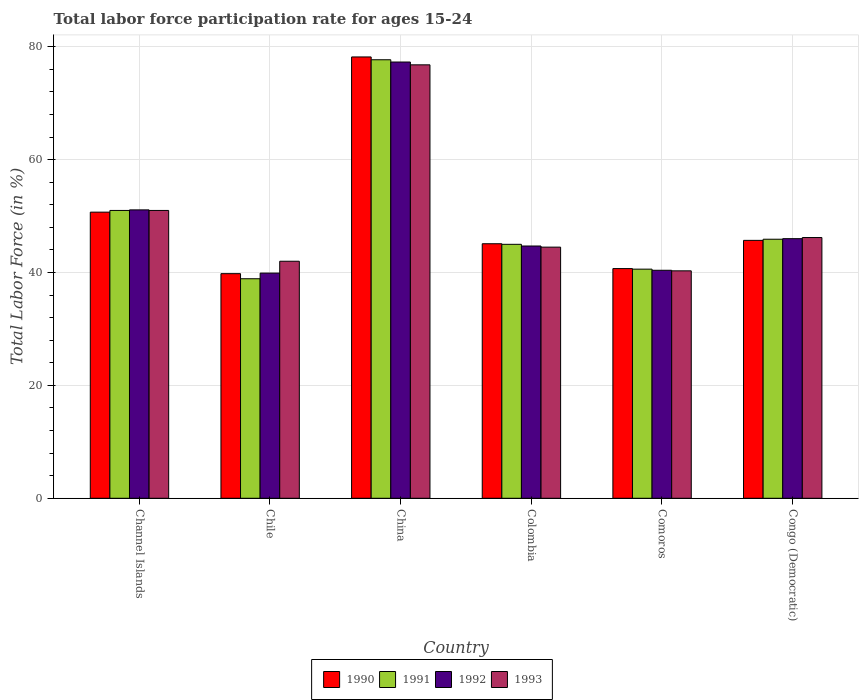How many different coloured bars are there?
Your answer should be very brief. 4. How many bars are there on the 1st tick from the right?
Give a very brief answer. 4. What is the label of the 3rd group of bars from the left?
Offer a terse response. China. In how many cases, is the number of bars for a given country not equal to the number of legend labels?
Give a very brief answer. 0. What is the labor force participation rate in 1991 in Chile?
Your answer should be compact. 38.9. Across all countries, what is the maximum labor force participation rate in 1992?
Give a very brief answer. 77.3. Across all countries, what is the minimum labor force participation rate in 1992?
Offer a terse response. 39.9. In which country was the labor force participation rate in 1991 minimum?
Keep it short and to the point. Chile. What is the total labor force participation rate in 1993 in the graph?
Your answer should be compact. 300.8. What is the difference between the labor force participation rate in 1990 in China and that in Congo (Democratic)?
Your response must be concise. 32.5. What is the difference between the labor force participation rate in 1990 in Channel Islands and the labor force participation rate in 1993 in Comoros?
Keep it short and to the point. 10.4. What is the average labor force participation rate in 1991 per country?
Keep it short and to the point. 49.85. What is the difference between the labor force participation rate of/in 1993 and labor force participation rate of/in 1991 in Congo (Democratic)?
Offer a very short reply. 0.3. In how many countries, is the labor force participation rate in 1991 greater than 36 %?
Your answer should be compact. 6. What is the ratio of the labor force participation rate in 1992 in Channel Islands to that in Chile?
Your answer should be compact. 1.28. Is the labor force participation rate in 1991 in Colombia less than that in Congo (Democratic)?
Your answer should be compact. Yes. Is the difference between the labor force participation rate in 1993 in Colombia and Comoros greater than the difference between the labor force participation rate in 1991 in Colombia and Comoros?
Give a very brief answer. No. What is the difference between the highest and the second highest labor force participation rate in 1992?
Offer a very short reply. -26.2. What is the difference between the highest and the lowest labor force participation rate in 1992?
Offer a terse response. 37.4. In how many countries, is the labor force participation rate in 1992 greater than the average labor force participation rate in 1992 taken over all countries?
Offer a terse response. 2. Is it the case that in every country, the sum of the labor force participation rate in 1992 and labor force participation rate in 1990 is greater than the sum of labor force participation rate in 1991 and labor force participation rate in 1993?
Offer a very short reply. No. What does the 3rd bar from the right in China represents?
Your response must be concise. 1991. Is it the case that in every country, the sum of the labor force participation rate in 1992 and labor force participation rate in 1993 is greater than the labor force participation rate in 1990?
Ensure brevity in your answer.  Yes. Are all the bars in the graph horizontal?
Provide a short and direct response. No. Does the graph contain grids?
Provide a short and direct response. Yes. How are the legend labels stacked?
Offer a terse response. Horizontal. What is the title of the graph?
Your response must be concise. Total labor force participation rate for ages 15-24. What is the label or title of the X-axis?
Make the answer very short. Country. What is the Total Labor Force (in %) in 1990 in Channel Islands?
Provide a short and direct response. 50.7. What is the Total Labor Force (in %) in 1991 in Channel Islands?
Your answer should be compact. 51. What is the Total Labor Force (in %) of 1992 in Channel Islands?
Give a very brief answer. 51.1. What is the Total Labor Force (in %) of 1993 in Channel Islands?
Your answer should be compact. 51. What is the Total Labor Force (in %) in 1990 in Chile?
Provide a succinct answer. 39.8. What is the Total Labor Force (in %) in 1991 in Chile?
Make the answer very short. 38.9. What is the Total Labor Force (in %) in 1992 in Chile?
Your answer should be compact. 39.9. What is the Total Labor Force (in %) in 1993 in Chile?
Offer a very short reply. 42. What is the Total Labor Force (in %) in 1990 in China?
Provide a short and direct response. 78.2. What is the Total Labor Force (in %) of 1991 in China?
Ensure brevity in your answer.  77.7. What is the Total Labor Force (in %) in 1992 in China?
Your answer should be very brief. 77.3. What is the Total Labor Force (in %) of 1993 in China?
Your response must be concise. 76.8. What is the Total Labor Force (in %) of 1990 in Colombia?
Your answer should be very brief. 45.1. What is the Total Labor Force (in %) of 1991 in Colombia?
Your answer should be compact. 45. What is the Total Labor Force (in %) in 1992 in Colombia?
Offer a terse response. 44.7. What is the Total Labor Force (in %) in 1993 in Colombia?
Offer a very short reply. 44.5. What is the Total Labor Force (in %) of 1990 in Comoros?
Your answer should be very brief. 40.7. What is the Total Labor Force (in %) of 1991 in Comoros?
Your answer should be compact. 40.6. What is the Total Labor Force (in %) in 1992 in Comoros?
Keep it short and to the point. 40.4. What is the Total Labor Force (in %) of 1993 in Comoros?
Your response must be concise. 40.3. What is the Total Labor Force (in %) in 1990 in Congo (Democratic)?
Offer a very short reply. 45.7. What is the Total Labor Force (in %) of 1991 in Congo (Democratic)?
Keep it short and to the point. 45.9. What is the Total Labor Force (in %) of 1993 in Congo (Democratic)?
Your answer should be very brief. 46.2. Across all countries, what is the maximum Total Labor Force (in %) of 1990?
Give a very brief answer. 78.2. Across all countries, what is the maximum Total Labor Force (in %) in 1991?
Ensure brevity in your answer.  77.7. Across all countries, what is the maximum Total Labor Force (in %) of 1992?
Ensure brevity in your answer.  77.3. Across all countries, what is the maximum Total Labor Force (in %) of 1993?
Keep it short and to the point. 76.8. Across all countries, what is the minimum Total Labor Force (in %) of 1990?
Offer a terse response. 39.8. Across all countries, what is the minimum Total Labor Force (in %) in 1991?
Give a very brief answer. 38.9. Across all countries, what is the minimum Total Labor Force (in %) of 1992?
Offer a terse response. 39.9. Across all countries, what is the minimum Total Labor Force (in %) of 1993?
Your response must be concise. 40.3. What is the total Total Labor Force (in %) of 1990 in the graph?
Make the answer very short. 300.2. What is the total Total Labor Force (in %) in 1991 in the graph?
Ensure brevity in your answer.  299.1. What is the total Total Labor Force (in %) in 1992 in the graph?
Make the answer very short. 299.4. What is the total Total Labor Force (in %) in 1993 in the graph?
Your answer should be compact. 300.8. What is the difference between the Total Labor Force (in %) in 1991 in Channel Islands and that in Chile?
Your answer should be very brief. 12.1. What is the difference between the Total Labor Force (in %) of 1990 in Channel Islands and that in China?
Offer a terse response. -27.5. What is the difference between the Total Labor Force (in %) in 1991 in Channel Islands and that in China?
Provide a short and direct response. -26.7. What is the difference between the Total Labor Force (in %) of 1992 in Channel Islands and that in China?
Ensure brevity in your answer.  -26.2. What is the difference between the Total Labor Force (in %) of 1993 in Channel Islands and that in China?
Ensure brevity in your answer.  -25.8. What is the difference between the Total Labor Force (in %) in 1990 in Channel Islands and that in Colombia?
Your answer should be compact. 5.6. What is the difference between the Total Labor Force (in %) of 1991 in Channel Islands and that in Colombia?
Give a very brief answer. 6. What is the difference between the Total Labor Force (in %) of 1992 in Channel Islands and that in Colombia?
Your answer should be compact. 6.4. What is the difference between the Total Labor Force (in %) in 1990 in Channel Islands and that in Comoros?
Ensure brevity in your answer.  10. What is the difference between the Total Labor Force (in %) of 1991 in Channel Islands and that in Comoros?
Your response must be concise. 10.4. What is the difference between the Total Labor Force (in %) in 1993 in Channel Islands and that in Comoros?
Your response must be concise. 10.7. What is the difference between the Total Labor Force (in %) in 1990 in Channel Islands and that in Congo (Democratic)?
Offer a very short reply. 5. What is the difference between the Total Labor Force (in %) of 1993 in Channel Islands and that in Congo (Democratic)?
Offer a terse response. 4.8. What is the difference between the Total Labor Force (in %) of 1990 in Chile and that in China?
Make the answer very short. -38.4. What is the difference between the Total Labor Force (in %) of 1991 in Chile and that in China?
Provide a succinct answer. -38.8. What is the difference between the Total Labor Force (in %) in 1992 in Chile and that in China?
Offer a very short reply. -37.4. What is the difference between the Total Labor Force (in %) of 1993 in Chile and that in China?
Provide a succinct answer. -34.8. What is the difference between the Total Labor Force (in %) in 1990 in Chile and that in Colombia?
Your response must be concise. -5.3. What is the difference between the Total Labor Force (in %) of 1993 in Chile and that in Colombia?
Provide a short and direct response. -2.5. What is the difference between the Total Labor Force (in %) in 1992 in Chile and that in Comoros?
Keep it short and to the point. -0.5. What is the difference between the Total Labor Force (in %) of 1993 in Chile and that in Comoros?
Give a very brief answer. 1.7. What is the difference between the Total Labor Force (in %) of 1990 in Chile and that in Congo (Democratic)?
Keep it short and to the point. -5.9. What is the difference between the Total Labor Force (in %) of 1990 in China and that in Colombia?
Your answer should be compact. 33.1. What is the difference between the Total Labor Force (in %) of 1991 in China and that in Colombia?
Give a very brief answer. 32.7. What is the difference between the Total Labor Force (in %) of 1992 in China and that in Colombia?
Keep it short and to the point. 32.6. What is the difference between the Total Labor Force (in %) of 1993 in China and that in Colombia?
Offer a terse response. 32.3. What is the difference between the Total Labor Force (in %) of 1990 in China and that in Comoros?
Give a very brief answer. 37.5. What is the difference between the Total Labor Force (in %) of 1991 in China and that in Comoros?
Make the answer very short. 37.1. What is the difference between the Total Labor Force (in %) of 1992 in China and that in Comoros?
Offer a terse response. 36.9. What is the difference between the Total Labor Force (in %) in 1993 in China and that in Comoros?
Ensure brevity in your answer.  36.5. What is the difference between the Total Labor Force (in %) of 1990 in China and that in Congo (Democratic)?
Your answer should be very brief. 32.5. What is the difference between the Total Labor Force (in %) of 1991 in China and that in Congo (Democratic)?
Give a very brief answer. 31.8. What is the difference between the Total Labor Force (in %) of 1992 in China and that in Congo (Democratic)?
Your response must be concise. 31.3. What is the difference between the Total Labor Force (in %) of 1993 in China and that in Congo (Democratic)?
Ensure brevity in your answer.  30.6. What is the difference between the Total Labor Force (in %) in 1990 in Colombia and that in Comoros?
Your response must be concise. 4.4. What is the difference between the Total Labor Force (in %) of 1991 in Colombia and that in Comoros?
Provide a succinct answer. 4.4. What is the difference between the Total Labor Force (in %) in 1993 in Colombia and that in Comoros?
Your answer should be compact. 4.2. What is the difference between the Total Labor Force (in %) in 1990 in Colombia and that in Congo (Democratic)?
Offer a very short reply. -0.6. What is the difference between the Total Labor Force (in %) in 1993 in Comoros and that in Congo (Democratic)?
Keep it short and to the point. -5.9. What is the difference between the Total Labor Force (in %) of 1990 in Channel Islands and the Total Labor Force (in %) of 1991 in Chile?
Your response must be concise. 11.8. What is the difference between the Total Labor Force (in %) in 1990 in Channel Islands and the Total Labor Force (in %) in 1992 in Chile?
Your response must be concise. 10.8. What is the difference between the Total Labor Force (in %) of 1991 in Channel Islands and the Total Labor Force (in %) of 1992 in Chile?
Give a very brief answer. 11.1. What is the difference between the Total Labor Force (in %) in 1991 in Channel Islands and the Total Labor Force (in %) in 1993 in Chile?
Your response must be concise. 9. What is the difference between the Total Labor Force (in %) in 1990 in Channel Islands and the Total Labor Force (in %) in 1991 in China?
Your answer should be very brief. -27. What is the difference between the Total Labor Force (in %) in 1990 in Channel Islands and the Total Labor Force (in %) in 1992 in China?
Make the answer very short. -26.6. What is the difference between the Total Labor Force (in %) in 1990 in Channel Islands and the Total Labor Force (in %) in 1993 in China?
Provide a succinct answer. -26.1. What is the difference between the Total Labor Force (in %) of 1991 in Channel Islands and the Total Labor Force (in %) of 1992 in China?
Give a very brief answer. -26.3. What is the difference between the Total Labor Force (in %) of 1991 in Channel Islands and the Total Labor Force (in %) of 1993 in China?
Offer a terse response. -25.8. What is the difference between the Total Labor Force (in %) of 1992 in Channel Islands and the Total Labor Force (in %) of 1993 in China?
Offer a very short reply. -25.7. What is the difference between the Total Labor Force (in %) of 1990 in Channel Islands and the Total Labor Force (in %) of 1991 in Colombia?
Provide a short and direct response. 5.7. What is the difference between the Total Labor Force (in %) of 1990 in Channel Islands and the Total Labor Force (in %) of 1992 in Colombia?
Your response must be concise. 6. What is the difference between the Total Labor Force (in %) of 1991 in Channel Islands and the Total Labor Force (in %) of 1992 in Colombia?
Make the answer very short. 6.3. What is the difference between the Total Labor Force (in %) of 1991 in Channel Islands and the Total Labor Force (in %) of 1993 in Colombia?
Offer a very short reply. 6.5. What is the difference between the Total Labor Force (in %) in 1992 in Channel Islands and the Total Labor Force (in %) in 1993 in Colombia?
Keep it short and to the point. 6.6. What is the difference between the Total Labor Force (in %) in 1990 in Channel Islands and the Total Labor Force (in %) in 1991 in Comoros?
Provide a succinct answer. 10.1. What is the difference between the Total Labor Force (in %) in 1991 in Channel Islands and the Total Labor Force (in %) in 1993 in Comoros?
Give a very brief answer. 10.7. What is the difference between the Total Labor Force (in %) of 1992 in Channel Islands and the Total Labor Force (in %) of 1993 in Comoros?
Keep it short and to the point. 10.8. What is the difference between the Total Labor Force (in %) of 1990 in Channel Islands and the Total Labor Force (in %) of 1991 in Congo (Democratic)?
Offer a terse response. 4.8. What is the difference between the Total Labor Force (in %) in 1990 in Channel Islands and the Total Labor Force (in %) in 1992 in Congo (Democratic)?
Keep it short and to the point. 4.7. What is the difference between the Total Labor Force (in %) of 1990 in Chile and the Total Labor Force (in %) of 1991 in China?
Your response must be concise. -37.9. What is the difference between the Total Labor Force (in %) in 1990 in Chile and the Total Labor Force (in %) in 1992 in China?
Keep it short and to the point. -37.5. What is the difference between the Total Labor Force (in %) of 1990 in Chile and the Total Labor Force (in %) of 1993 in China?
Keep it short and to the point. -37. What is the difference between the Total Labor Force (in %) of 1991 in Chile and the Total Labor Force (in %) of 1992 in China?
Your answer should be very brief. -38.4. What is the difference between the Total Labor Force (in %) in 1991 in Chile and the Total Labor Force (in %) in 1993 in China?
Give a very brief answer. -37.9. What is the difference between the Total Labor Force (in %) in 1992 in Chile and the Total Labor Force (in %) in 1993 in China?
Keep it short and to the point. -36.9. What is the difference between the Total Labor Force (in %) in 1990 in Chile and the Total Labor Force (in %) in 1992 in Colombia?
Offer a very short reply. -4.9. What is the difference between the Total Labor Force (in %) of 1990 in Chile and the Total Labor Force (in %) of 1993 in Colombia?
Ensure brevity in your answer.  -4.7. What is the difference between the Total Labor Force (in %) in 1991 in Chile and the Total Labor Force (in %) in 1992 in Colombia?
Your response must be concise. -5.8. What is the difference between the Total Labor Force (in %) in 1991 in Chile and the Total Labor Force (in %) in 1993 in Colombia?
Keep it short and to the point. -5.6. What is the difference between the Total Labor Force (in %) of 1990 in Chile and the Total Labor Force (in %) of 1992 in Comoros?
Your response must be concise. -0.6. What is the difference between the Total Labor Force (in %) of 1990 in Chile and the Total Labor Force (in %) of 1993 in Comoros?
Provide a succinct answer. -0.5. What is the difference between the Total Labor Force (in %) of 1991 in Chile and the Total Labor Force (in %) of 1993 in Comoros?
Offer a terse response. -1.4. What is the difference between the Total Labor Force (in %) of 1990 in Chile and the Total Labor Force (in %) of 1991 in Congo (Democratic)?
Keep it short and to the point. -6.1. What is the difference between the Total Labor Force (in %) of 1990 in Chile and the Total Labor Force (in %) of 1992 in Congo (Democratic)?
Provide a succinct answer. -6.2. What is the difference between the Total Labor Force (in %) of 1990 in Chile and the Total Labor Force (in %) of 1993 in Congo (Democratic)?
Provide a succinct answer. -6.4. What is the difference between the Total Labor Force (in %) in 1991 in Chile and the Total Labor Force (in %) in 1992 in Congo (Democratic)?
Your response must be concise. -7.1. What is the difference between the Total Labor Force (in %) of 1991 in Chile and the Total Labor Force (in %) of 1993 in Congo (Democratic)?
Your answer should be very brief. -7.3. What is the difference between the Total Labor Force (in %) of 1990 in China and the Total Labor Force (in %) of 1991 in Colombia?
Your response must be concise. 33.2. What is the difference between the Total Labor Force (in %) of 1990 in China and the Total Labor Force (in %) of 1992 in Colombia?
Provide a succinct answer. 33.5. What is the difference between the Total Labor Force (in %) of 1990 in China and the Total Labor Force (in %) of 1993 in Colombia?
Offer a terse response. 33.7. What is the difference between the Total Labor Force (in %) in 1991 in China and the Total Labor Force (in %) in 1993 in Colombia?
Provide a succinct answer. 33.2. What is the difference between the Total Labor Force (in %) in 1992 in China and the Total Labor Force (in %) in 1993 in Colombia?
Ensure brevity in your answer.  32.8. What is the difference between the Total Labor Force (in %) of 1990 in China and the Total Labor Force (in %) of 1991 in Comoros?
Offer a very short reply. 37.6. What is the difference between the Total Labor Force (in %) of 1990 in China and the Total Labor Force (in %) of 1992 in Comoros?
Provide a succinct answer. 37.8. What is the difference between the Total Labor Force (in %) of 1990 in China and the Total Labor Force (in %) of 1993 in Comoros?
Make the answer very short. 37.9. What is the difference between the Total Labor Force (in %) of 1991 in China and the Total Labor Force (in %) of 1992 in Comoros?
Ensure brevity in your answer.  37.3. What is the difference between the Total Labor Force (in %) in 1991 in China and the Total Labor Force (in %) in 1993 in Comoros?
Keep it short and to the point. 37.4. What is the difference between the Total Labor Force (in %) in 1990 in China and the Total Labor Force (in %) in 1991 in Congo (Democratic)?
Your answer should be very brief. 32.3. What is the difference between the Total Labor Force (in %) in 1990 in China and the Total Labor Force (in %) in 1992 in Congo (Democratic)?
Keep it short and to the point. 32.2. What is the difference between the Total Labor Force (in %) in 1990 in China and the Total Labor Force (in %) in 1993 in Congo (Democratic)?
Keep it short and to the point. 32. What is the difference between the Total Labor Force (in %) of 1991 in China and the Total Labor Force (in %) of 1992 in Congo (Democratic)?
Ensure brevity in your answer.  31.7. What is the difference between the Total Labor Force (in %) of 1991 in China and the Total Labor Force (in %) of 1993 in Congo (Democratic)?
Your answer should be compact. 31.5. What is the difference between the Total Labor Force (in %) in 1992 in China and the Total Labor Force (in %) in 1993 in Congo (Democratic)?
Give a very brief answer. 31.1. What is the difference between the Total Labor Force (in %) in 1990 in Colombia and the Total Labor Force (in %) in 1991 in Comoros?
Your answer should be compact. 4.5. What is the difference between the Total Labor Force (in %) in 1991 in Colombia and the Total Labor Force (in %) in 1992 in Comoros?
Give a very brief answer. 4.6. What is the difference between the Total Labor Force (in %) of 1992 in Colombia and the Total Labor Force (in %) of 1993 in Comoros?
Provide a succinct answer. 4.4. What is the difference between the Total Labor Force (in %) of 1990 in Colombia and the Total Labor Force (in %) of 1991 in Congo (Democratic)?
Provide a short and direct response. -0.8. What is the difference between the Total Labor Force (in %) of 1991 in Colombia and the Total Labor Force (in %) of 1992 in Congo (Democratic)?
Keep it short and to the point. -1. What is the difference between the Total Labor Force (in %) in 1990 in Comoros and the Total Labor Force (in %) in 1991 in Congo (Democratic)?
Offer a very short reply. -5.2. What is the difference between the Total Labor Force (in %) in 1990 in Comoros and the Total Labor Force (in %) in 1993 in Congo (Democratic)?
Provide a short and direct response. -5.5. What is the difference between the Total Labor Force (in %) in 1991 in Comoros and the Total Labor Force (in %) in 1993 in Congo (Democratic)?
Your answer should be compact. -5.6. What is the difference between the Total Labor Force (in %) in 1992 in Comoros and the Total Labor Force (in %) in 1993 in Congo (Democratic)?
Your answer should be very brief. -5.8. What is the average Total Labor Force (in %) of 1990 per country?
Give a very brief answer. 50.03. What is the average Total Labor Force (in %) of 1991 per country?
Offer a terse response. 49.85. What is the average Total Labor Force (in %) in 1992 per country?
Offer a very short reply. 49.9. What is the average Total Labor Force (in %) of 1993 per country?
Make the answer very short. 50.13. What is the difference between the Total Labor Force (in %) of 1990 and Total Labor Force (in %) of 1991 in Channel Islands?
Offer a very short reply. -0.3. What is the difference between the Total Labor Force (in %) in 1990 and Total Labor Force (in %) in 1993 in Channel Islands?
Your answer should be very brief. -0.3. What is the difference between the Total Labor Force (in %) of 1991 and Total Labor Force (in %) of 1992 in Channel Islands?
Your response must be concise. -0.1. What is the difference between the Total Labor Force (in %) in 1992 and Total Labor Force (in %) in 1993 in Channel Islands?
Keep it short and to the point. 0.1. What is the difference between the Total Labor Force (in %) of 1991 and Total Labor Force (in %) of 1992 in Chile?
Your answer should be very brief. -1. What is the difference between the Total Labor Force (in %) in 1990 and Total Labor Force (in %) in 1992 in China?
Give a very brief answer. 0.9. What is the difference between the Total Labor Force (in %) in 1990 and Total Labor Force (in %) in 1993 in China?
Make the answer very short. 1.4. What is the difference between the Total Labor Force (in %) in 1991 and Total Labor Force (in %) in 1992 in China?
Offer a terse response. 0.4. What is the difference between the Total Labor Force (in %) of 1991 and Total Labor Force (in %) of 1993 in China?
Give a very brief answer. 0.9. What is the difference between the Total Labor Force (in %) of 1990 and Total Labor Force (in %) of 1992 in Colombia?
Give a very brief answer. 0.4. What is the difference between the Total Labor Force (in %) of 1990 and Total Labor Force (in %) of 1992 in Comoros?
Ensure brevity in your answer.  0.3. What is the difference between the Total Labor Force (in %) in 1991 and Total Labor Force (in %) in 1993 in Comoros?
Provide a succinct answer. 0.3. What is the difference between the Total Labor Force (in %) in 1992 and Total Labor Force (in %) in 1993 in Comoros?
Your response must be concise. 0.1. What is the difference between the Total Labor Force (in %) in 1990 and Total Labor Force (in %) in 1991 in Congo (Democratic)?
Your answer should be compact. -0.2. What is the difference between the Total Labor Force (in %) of 1991 and Total Labor Force (in %) of 1992 in Congo (Democratic)?
Offer a terse response. -0.1. What is the difference between the Total Labor Force (in %) of 1991 and Total Labor Force (in %) of 1993 in Congo (Democratic)?
Your answer should be compact. -0.3. What is the ratio of the Total Labor Force (in %) of 1990 in Channel Islands to that in Chile?
Provide a succinct answer. 1.27. What is the ratio of the Total Labor Force (in %) in 1991 in Channel Islands to that in Chile?
Make the answer very short. 1.31. What is the ratio of the Total Labor Force (in %) of 1992 in Channel Islands to that in Chile?
Give a very brief answer. 1.28. What is the ratio of the Total Labor Force (in %) of 1993 in Channel Islands to that in Chile?
Offer a very short reply. 1.21. What is the ratio of the Total Labor Force (in %) of 1990 in Channel Islands to that in China?
Ensure brevity in your answer.  0.65. What is the ratio of the Total Labor Force (in %) in 1991 in Channel Islands to that in China?
Ensure brevity in your answer.  0.66. What is the ratio of the Total Labor Force (in %) of 1992 in Channel Islands to that in China?
Your answer should be compact. 0.66. What is the ratio of the Total Labor Force (in %) in 1993 in Channel Islands to that in China?
Offer a terse response. 0.66. What is the ratio of the Total Labor Force (in %) in 1990 in Channel Islands to that in Colombia?
Provide a short and direct response. 1.12. What is the ratio of the Total Labor Force (in %) in 1991 in Channel Islands to that in Colombia?
Your answer should be compact. 1.13. What is the ratio of the Total Labor Force (in %) of 1992 in Channel Islands to that in Colombia?
Your answer should be compact. 1.14. What is the ratio of the Total Labor Force (in %) of 1993 in Channel Islands to that in Colombia?
Give a very brief answer. 1.15. What is the ratio of the Total Labor Force (in %) in 1990 in Channel Islands to that in Comoros?
Keep it short and to the point. 1.25. What is the ratio of the Total Labor Force (in %) of 1991 in Channel Islands to that in Comoros?
Your response must be concise. 1.26. What is the ratio of the Total Labor Force (in %) in 1992 in Channel Islands to that in Comoros?
Give a very brief answer. 1.26. What is the ratio of the Total Labor Force (in %) of 1993 in Channel Islands to that in Comoros?
Your answer should be very brief. 1.27. What is the ratio of the Total Labor Force (in %) in 1990 in Channel Islands to that in Congo (Democratic)?
Provide a short and direct response. 1.11. What is the ratio of the Total Labor Force (in %) in 1992 in Channel Islands to that in Congo (Democratic)?
Offer a very short reply. 1.11. What is the ratio of the Total Labor Force (in %) of 1993 in Channel Islands to that in Congo (Democratic)?
Keep it short and to the point. 1.1. What is the ratio of the Total Labor Force (in %) in 1990 in Chile to that in China?
Ensure brevity in your answer.  0.51. What is the ratio of the Total Labor Force (in %) of 1991 in Chile to that in China?
Your answer should be compact. 0.5. What is the ratio of the Total Labor Force (in %) of 1992 in Chile to that in China?
Ensure brevity in your answer.  0.52. What is the ratio of the Total Labor Force (in %) of 1993 in Chile to that in China?
Your answer should be compact. 0.55. What is the ratio of the Total Labor Force (in %) in 1990 in Chile to that in Colombia?
Give a very brief answer. 0.88. What is the ratio of the Total Labor Force (in %) of 1991 in Chile to that in Colombia?
Offer a very short reply. 0.86. What is the ratio of the Total Labor Force (in %) of 1992 in Chile to that in Colombia?
Offer a terse response. 0.89. What is the ratio of the Total Labor Force (in %) of 1993 in Chile to that in Colombia?
Offer a terse response. 0.94. What is the ratio of the Total Labor Force (in %) of 1990 in Chile to that in Comoros?
Provide a short and direct response. 0.98. What is the ratio of the Total Labor Force (in %) of 1991 in Chile to that in Comoros?
Your response must be concise. 0.96. What is the ratio of the Total Labor Force (in %) of 1992 in Chile to that in Comoros?
Make the answer very short. 0.99. What is the ratio of the Total Labor Force (in %) in 1993 in Chile to that in Comoros?
Your answer should be very brief. 1.04. What is the ratio of the Total Labor Force (in %) of 1990 in Chile to that in Congo (Democratic)?
Your response must be concise. 0.87. What is the ratio of the Total Labor Force (in %) of 1991 in Chile to that in Congo (Democratic)?
Offer a terse response. 0.85. What is the ratio of the Total Labor Force (in %) in 1992 in Chile to that in Congo (Democratic)?
Ensure brevity in your answer.  0.87. What is the ratio of the Total Labor Force (in %) in 1993 in Chile to that in Congo (Democratic)?
Your response must be concise. 0.91. What is the ratio of the Total Labor Force (in %) of 1990 in China to that in Colombia?
Provide a succinct answer. 1.73. What is the ratio of the Total Labor Force (in %) in 1991 in China to that in Colombia?
Offer a terse response. 1.73. What is the ratio of the Total Labor Force (in %) of 1992 in China to that in Colombia?
Give a very brief answer. 1.73. What is the ratio of the Total Labor Force (in %) in 1993 in China to that in Colombia?
Keep it short and to the point. 1.73. What is the ratio of the Total Labor Force (in %) in 1990 in China to that in Comoros?
Give a very brief answer. 1.92. What is the ratio of the Total Labor Force (in %) in 1991 in China to that in Comoros?
Keep it short and to the point. 1.91. What is the ratio of the Total Labor Force (in %) in 1992 in China to that in Comoros?
Your answer should be very brief. 1.91. What is the ratio of the Total Labor Force (in %) of 1993 in China to that in Comoros?
Ensure brevity in your answer.  1.91. What is the ratio of the Total Labor Force (in %) in 1990 in China to that in Congo (Democratic)?
Keep it short and to the point. 1.71. What is the ratio of the Total Labor Force (in %) in 1991 in China to that in Congo (Democratic)?
Provide a succinct answer. 1.69. What is the ratio of the Total Labor Force (in %) in 1992 in China to that in Congo (Democratic)?
Provide a short and direct response. 1.68. What is the ratio of the Total Labor Force (in %) of 1993 in China to that in Congo (Democratic)?
Provide a short and direct response. 1.66. What is the ratio of the Total Labor Force (in %) in 1990 in Colombia to that in Comoros?
Your answer should be compact. 1.11. What is the ratio of the Total Labor Force (in %) in 1991 in Colombia to that in Comoros?
Provide a short and direct response. 1.11. What is the ratio of the Total Labor Force (in %) of 1992 in Colombia to that in Comoros?
Your answer should be compact. 1.11. What is the ratio of the Total Labor Force (in %) in 1993 in Colombia to that in Comoros?
Ensure brevity in your answer.  1.1. What is the ratio of the Total Labor Force (in %) of 1990 in Colombia to that in Congo (Democratic)?
Offer a terse response. 0.99. What is the ratio of the Total Labor Force (in %) in 1991 in Colombia to that in Congo (Democratic)?
Give a very brief answer. 0.98. What is the ratio of the Total Labor Force (in %) of 1992 in Colombia to that in Congo (Democratic)?
Keep it short and to the point. 0.97. What is the ratio of the Total Labor Force (in %) in 1993 in Colombia to that in Congo (Democratic)?
Make the answer very short. 0.96. What is the ratio of the Total Labor Force (in %) in 1990 in Comoros to that in Congo (Democratic)?
Keep it short and to the point. 0.89. What is the ratio of the Total Labor Force (in %) in 1991 in Comoros to that in Congo (Democratic)?
Your response must be concise. 0.88. What is the ratio of the Total Labor Force (in %) of 1992 in Comoros to that in Congo (Democratic)?
Your response must be concise. 0.88. What is the ratio of the Total Labor Force (in %) in 1993 in Comoros to that in Congo (Democratic)?
Keep it short and to the point. 0.87. What is the difference between the highest and the second highest Total Labor Force (in %) of 1991?
Make the answer very short. 26.7. What is the difference between the highest and the second highest Total Labor Force (in %) of 1992?
Offer a terse response. 26.2. What is the difference between the highest and the second highest Total Labor Force (in %) in 1993?
Provide a short and direct response. 25.8. What is the difference between the highest and the lowest Total Labor Force (in %) of 1990?
Your answer should be compact. 38.4. What is the difference between the highest and the lowest Total Labor Force (in %) of 1991?
Make the answer very short. 38.8. What is the difference between the highest and the lowest Total Labor Force (in %) of 1992?
Your answer should be very brief. 37.4. What is the difference between the highest and the lowest Total Labor Force (in %) of 1993?
Provide a short and direct response. 36.5. 